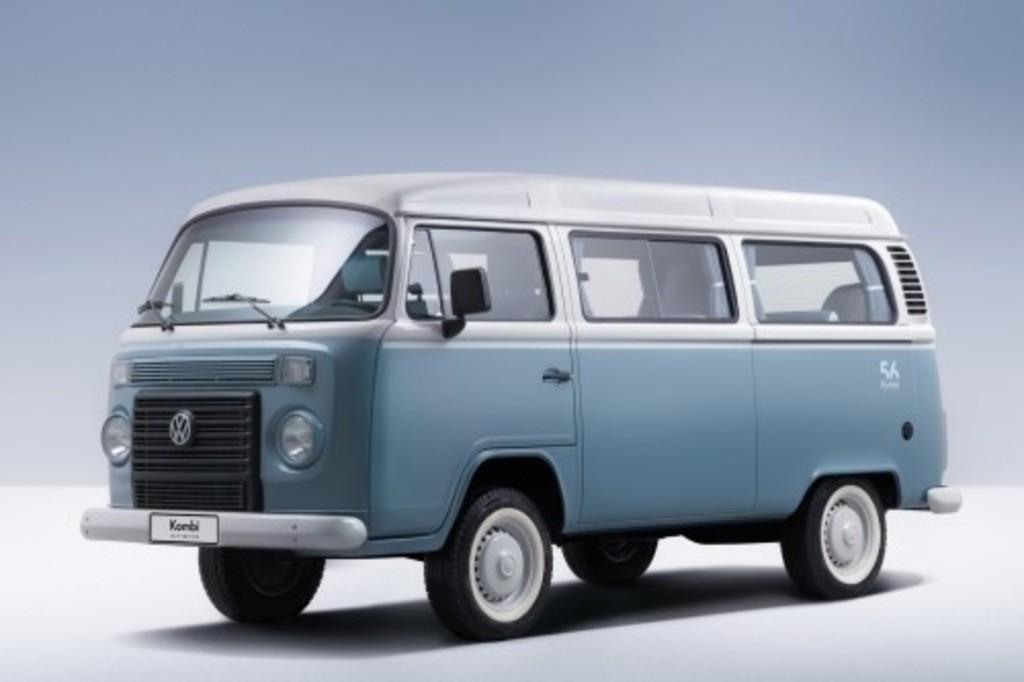What kind of van is this?
Make the answer very short. Vw. One of the type of van?
Your answer should be compact. Vw. 